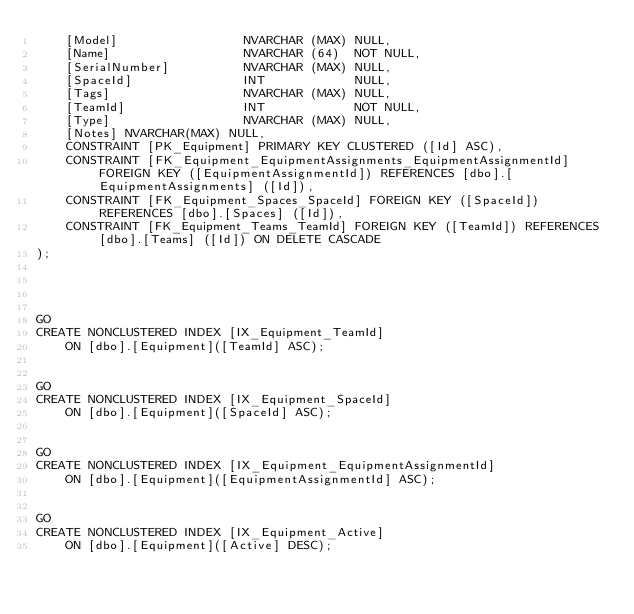<code> <loc_0><loc_0><loc_500><loc_500><_SQL_>    [Model]                 NVARCHAR (MAX) NULL,
    [Name]                  NVARCHAR (64)  NOT NULL,
    [SerialNumber]          NVARCHAR (MAX) NULL,
    [SpaceId]               INT            NULL,
    [Tags]                  NVARCHAR (MAX) NULL,
    [TeamId]                INT            NOT NULL,
    [Type]                  NVARCHAR (MAX) NULL,
    [Notes] NVARCHAR(MAX) NULL, 
    CONSTRAINT [PK_Equipment] PRIMARY KEY CLUSTERED ([Id] ASC),
    CONSTRAINT [FK_Equipment_EquipmentAssignments_EquipmentAssignmentId] FOREIGN KEY ([EquipmentAssignmentId]) REFERENCES [dbo].[EquipmentAssignments] ([Id]),
    CONSTRAINT [FK_Equipment_Spaces_SpaceId] FOREIGN KEY ([SpaceId]) REFERENCES [dbo].[Spaces] ([Id]),
    CONSTRAINT [FK_Equipment_Teams_TeamId] FOREIGN KEY ([TeamId]) REFERENCES [dbo].[Teams] ([Id]) ON DELETE CASCADE
);




GO
CREATE NONCLUSTERED INDEX [IX_Equipment_TeamId]
    ON [dbo].[Equipment]([TeamId] ASC);


GO
CREATE NONCLUSTERED INDEX [IX_Equipment_SpaceId]
    ON [dbo].[Equipment]([SpaceId] ASC);


GO
CREATE NONCLUSTERED INDEX [IX_Equipment_EquipmentAssignmentId]
    ON [dbo].[Equipment]([EquipmentAssignmentId] ASC);


GO
CREATE NONCLUSTERED INDEX [IX_Equipment_Active]
    ON [dbo].[Equipment]([Active] DESC);

</code> 